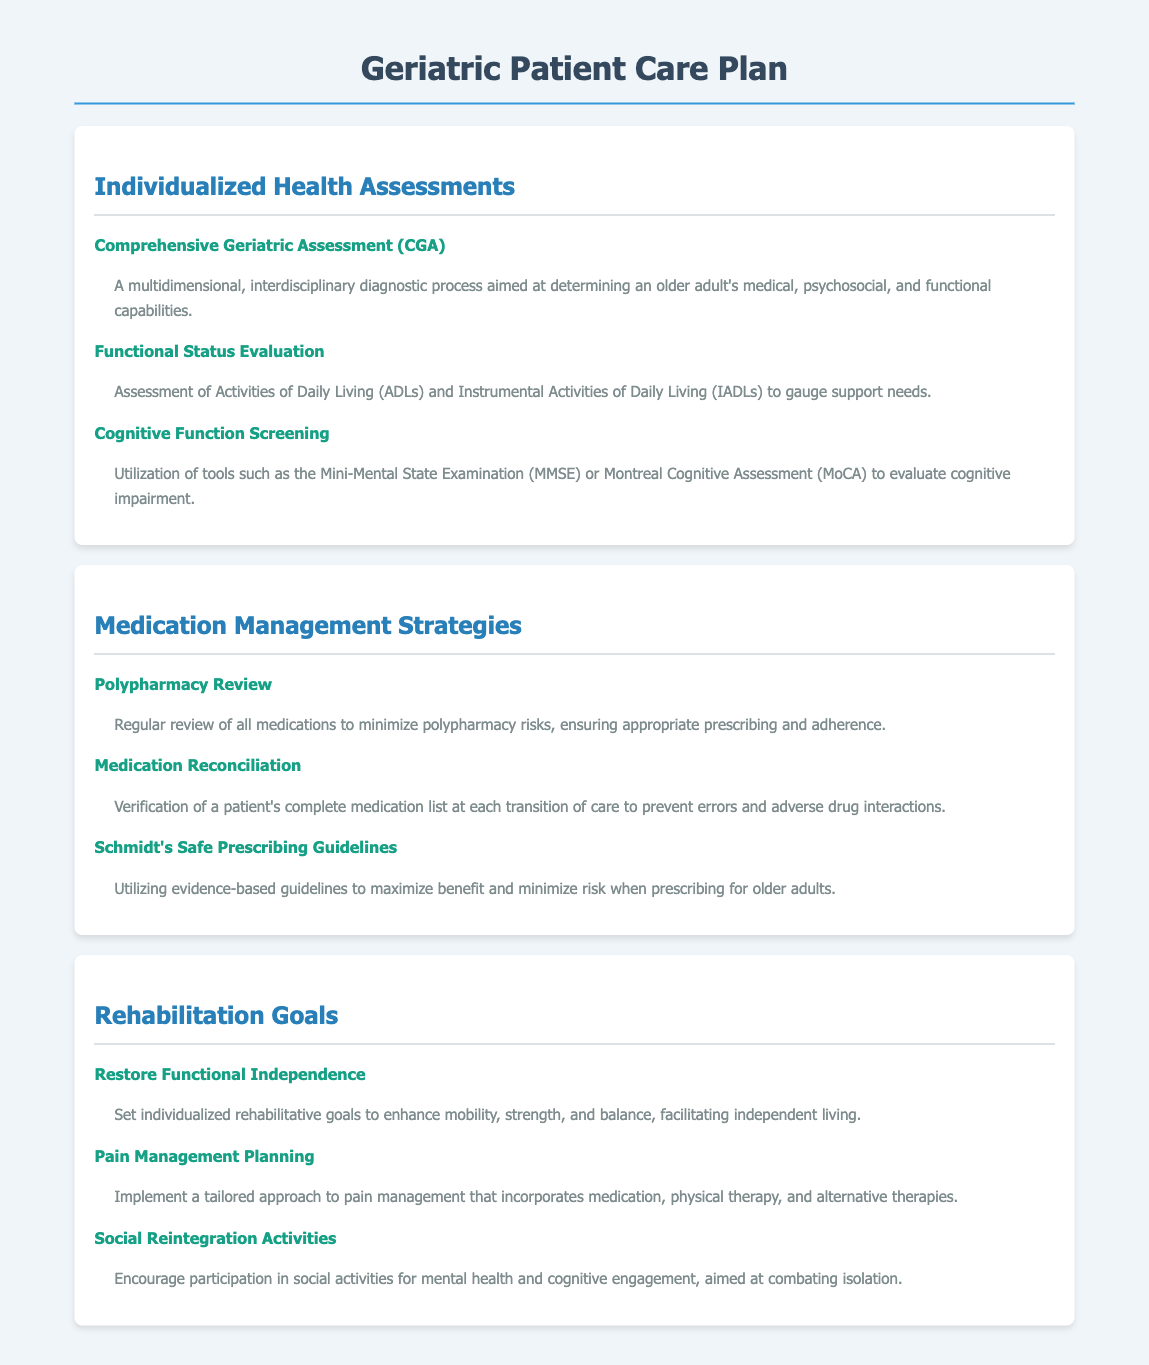What is the purpose of the Comprehensive Geriatric Assessment? It aims to determine an older adult's medical, psychosocial, and functional capabilities through a multidimensional, interdisciplinary diagnostic process.
Answer: A multidimensional, interdisciplinary diagnostic process What does ADLs stand for? ADLs refers to Activities of Daily Living, which are assessed along with Instrumental Activities of Daily Living (IADLs) for determining support needs.
Answer: Activities of Daily Living What screening tools are mentioned for cognitive function? The document mentions the Mini-Mental State Examination (MMSE) and Montreal Cognitive Assessment (MoCA) for evaluating cognitive impairment.
Answer: Mini-Mental State Examination (MMSE) and Montreal Cognitive Assessment (MoCA) How often should the Polypharmacy Review be conducted? The document implies that it should be conducted regularly to minimize polypharmacy risks, but does not specify a numerical frequency.
Answer: Regularly What is the goal for restoring functional independence? The goal is to enhance mobility, strength, and balance, which facilitates independent living.
Answer: Enhance mobility, strength, and balance What approach is suggested for pain management? A tailored approach is suggested that incorporates medication, physical therapy, and alternative therapies.
Answer: Tailored approach How many main sections are in the Geriatric Patient Care Plan? The document has three main sections: Individualized Health Assessments, Medication Management Strategies, and Rehabilitation Goals.
Answer: Three What guidelines are utilized for safe prescribing? Schmidt's Safe Prescribing Guidelines are referenced as evidence-based guidelines for maximizing benefit and minimizing risk when prescribing for older adults.
Answer: Schmidt's Safe Prescribing Guidelines 